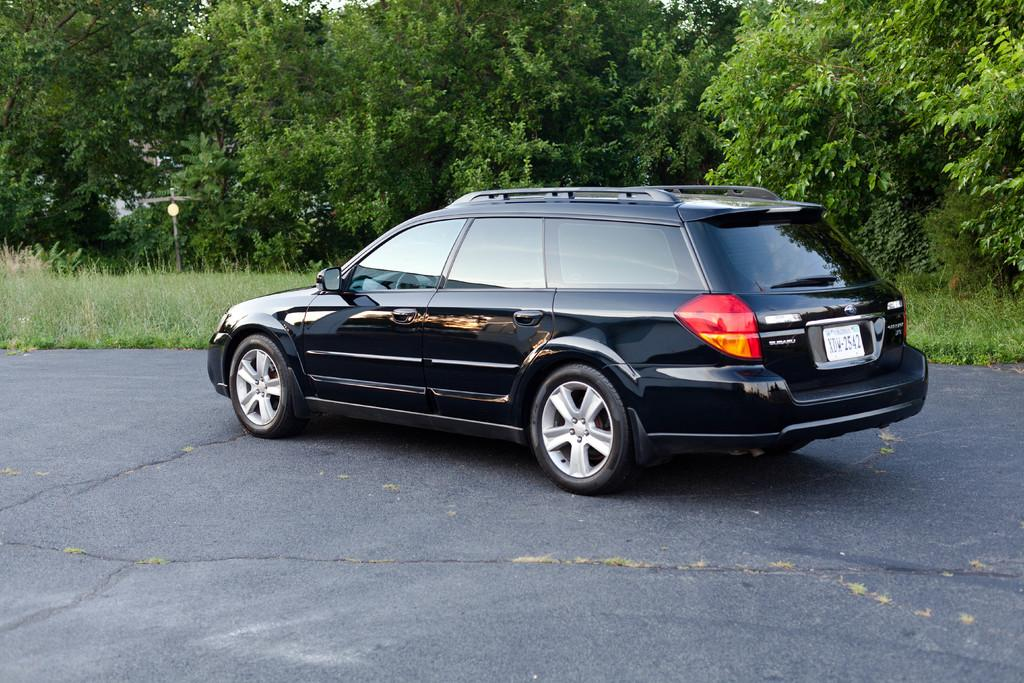What type of vehicle is in the image? There is a black car in the image. Where is the car located? The car is parked on the road. What can be seen behind the car? There is grass, a pole, and trees behind the car. Can you tell me how many horses are standing next to the car in the image? There are no horses present in the image; it features a black car parked on the road with grass, a pole, and trees behind it. 